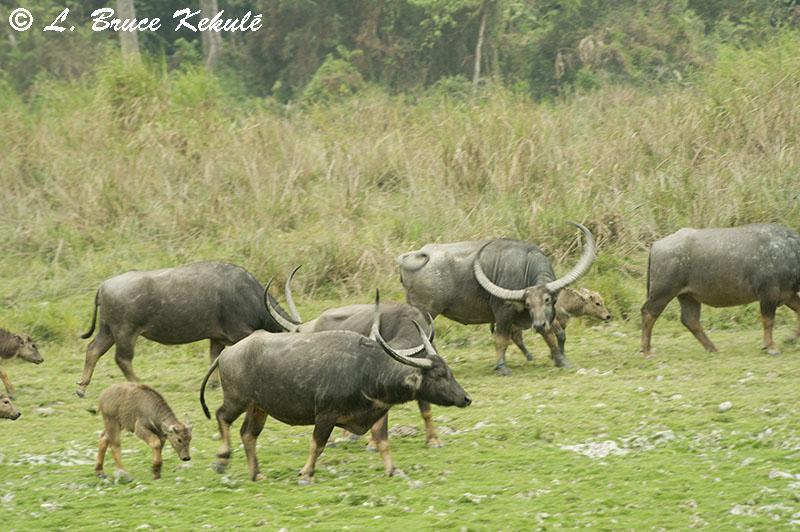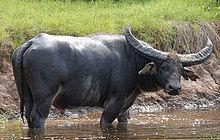The first image is the image on the left, the second image is the image on the right. Evaluate the accuracy of this statement regarding the images: "Two cows are in the picture on the left.". Is it true? Answer yes or no. No. The first image is the image on the left, the second image is the image on the right. For the images shown, is this caption "There are exactly two animals in the image on the left." true? Answer yes or no. No. 